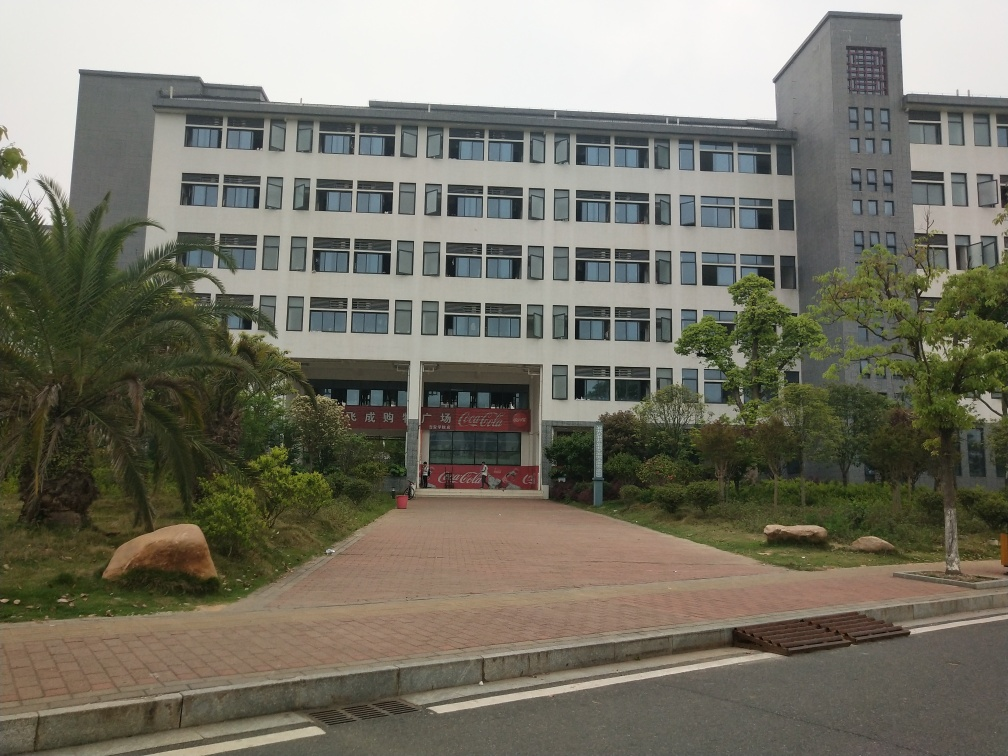Describe the surroundings of the building. The building is surrounded by well-maintained landscaping that includes shrubbery, palm trees, and what appears to be a neatly trimmed grass area. The pedestrian pathway leading to the building is made of bricks, and a couple of boulders are placed on either side, adding natural decorative elements to the scene. What is the weather like in the image? The sky appears overcast, and the lighting in the image is diffused, suggesting a cloudy day without direct sunlight. There are no shadows, which further points to an overcast weather condition. 